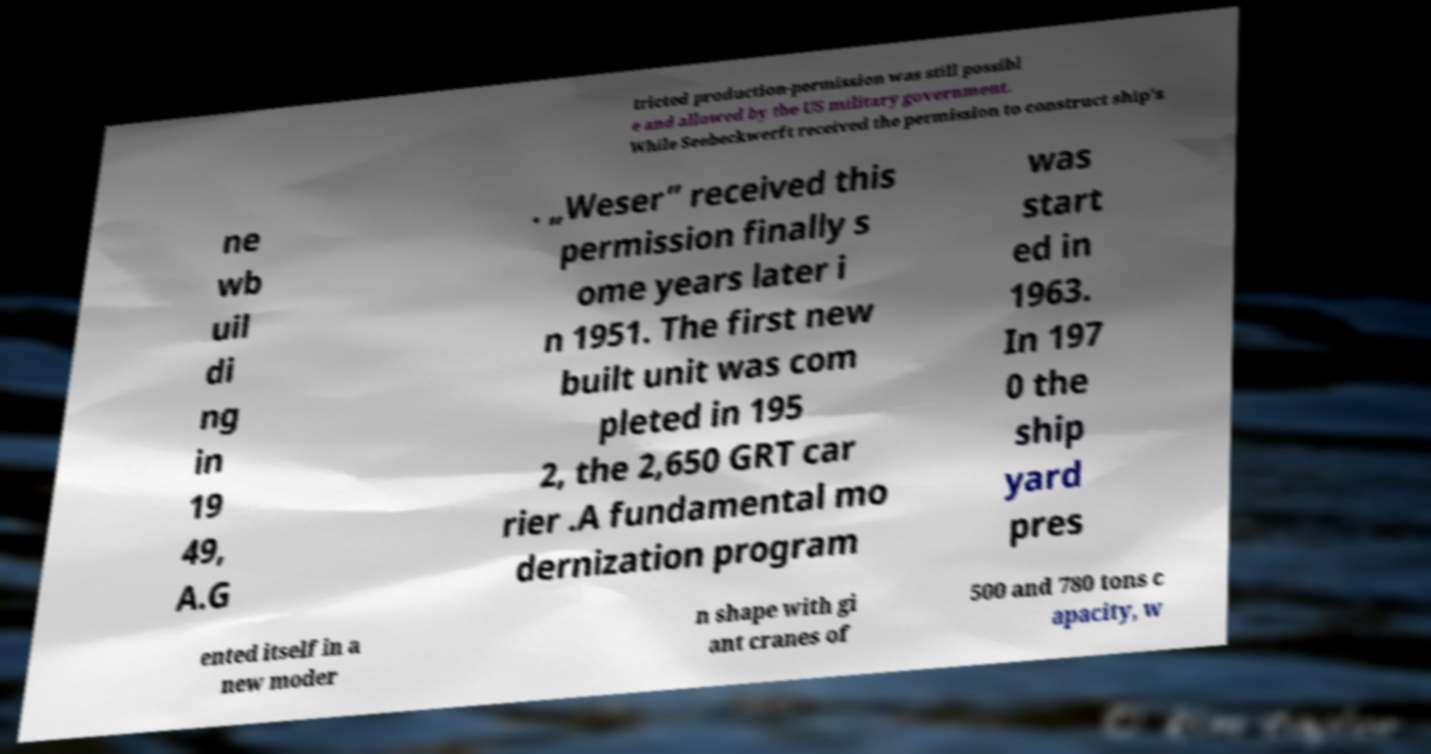Can you accurately transcribe the text from the provided image for me? tricted production-permission was still possibl e and allowed by the US military government. While Seebeckwerft received the permission to construct ship's ne wb uil di ng in 19 49, A.G . „Weser” received this permission finally s ome years later i n 1951. The first new built unit was com pleted in 195 2, the 2,650 GRT car rier .A fundamental mo dernization program was start ed in 1963. In 197 0 the ship yard pres ented itself in a new moder n shape with gi ant cranes of 500 and 780 tons c apacity, w 